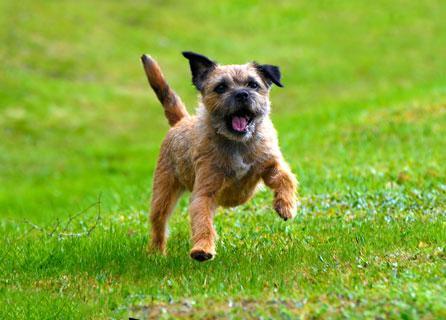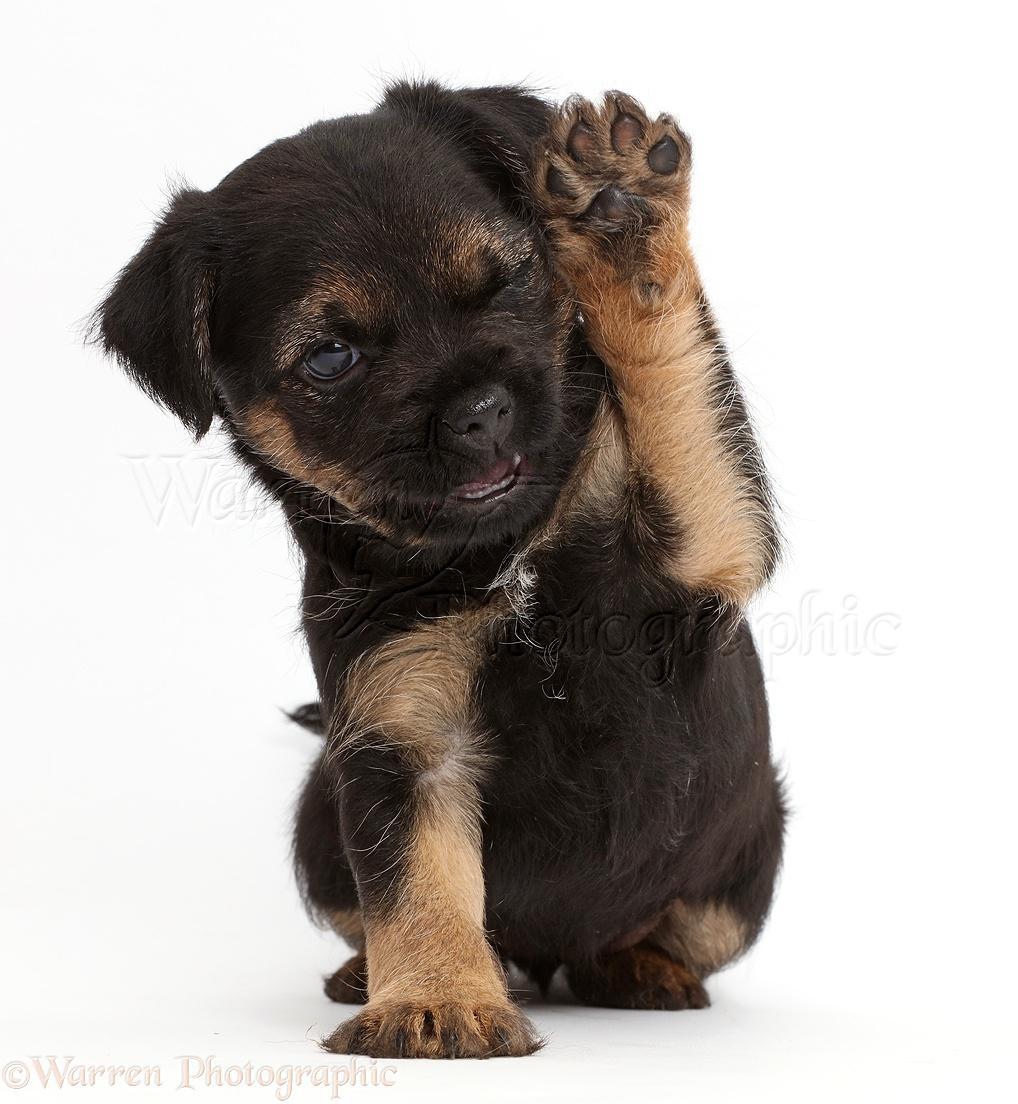The first image is the image on the left, the second image is the image on the right. Examine the images to the left and right. Is the description "In at least one image there is a single dog sitting facing right forward." accurate? Answer yes or no. No. The first image is the image on the left, the second image is the image on the right. For the images shown, is this caption "The puppy on the left is running, while the one on the right is not." true? Answer yes or no. Yes. 